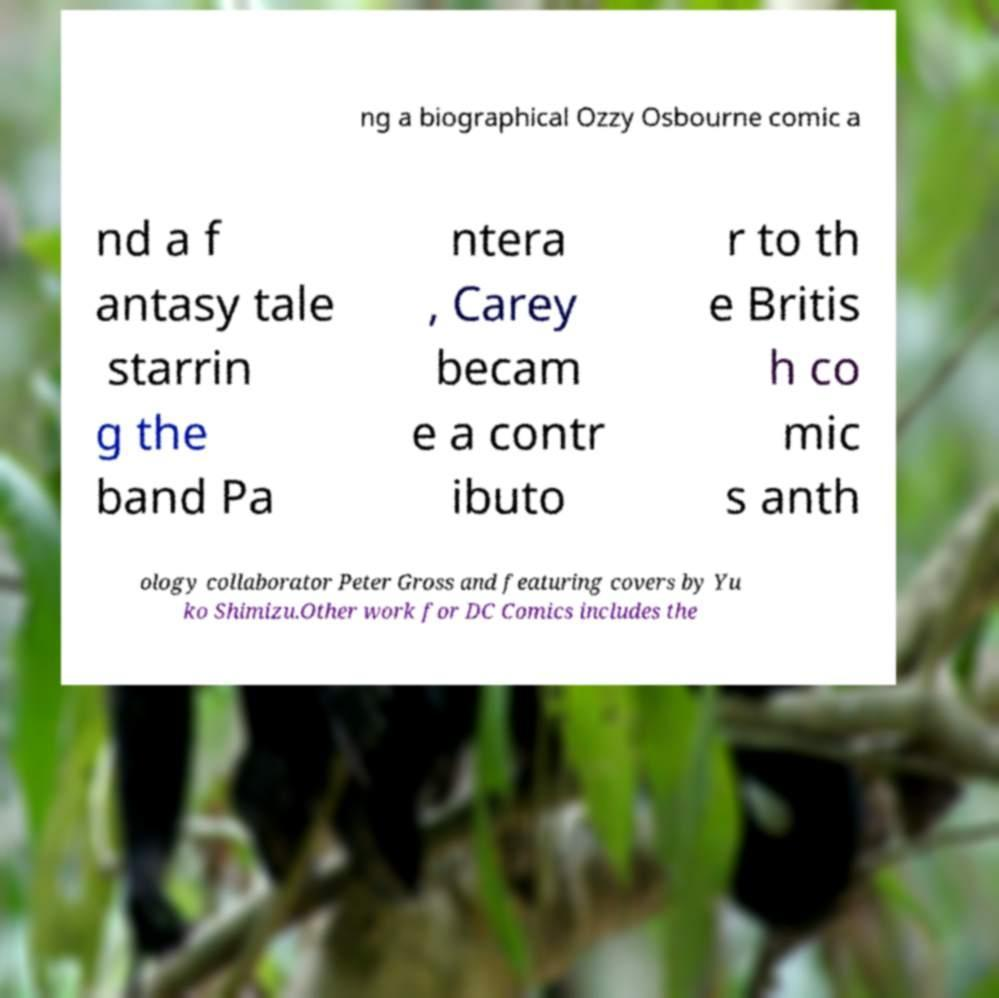Please read and relay the text visible in this image. What does it say? ng a biographical Ozzy Osbourne comic a nd a f antasy tale starrin g the band Pa ntera , Carey becam e a contr ibuto r to th e Britis h co mic s anth ology collaborator Peter Gross and featuring covers by Yu ko Shimizu.Other work for DC Comics includes the 